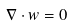<formula> <loc_0><loc_0><loc_500><loc_500>\nabla \cdot w = 0</formula> 